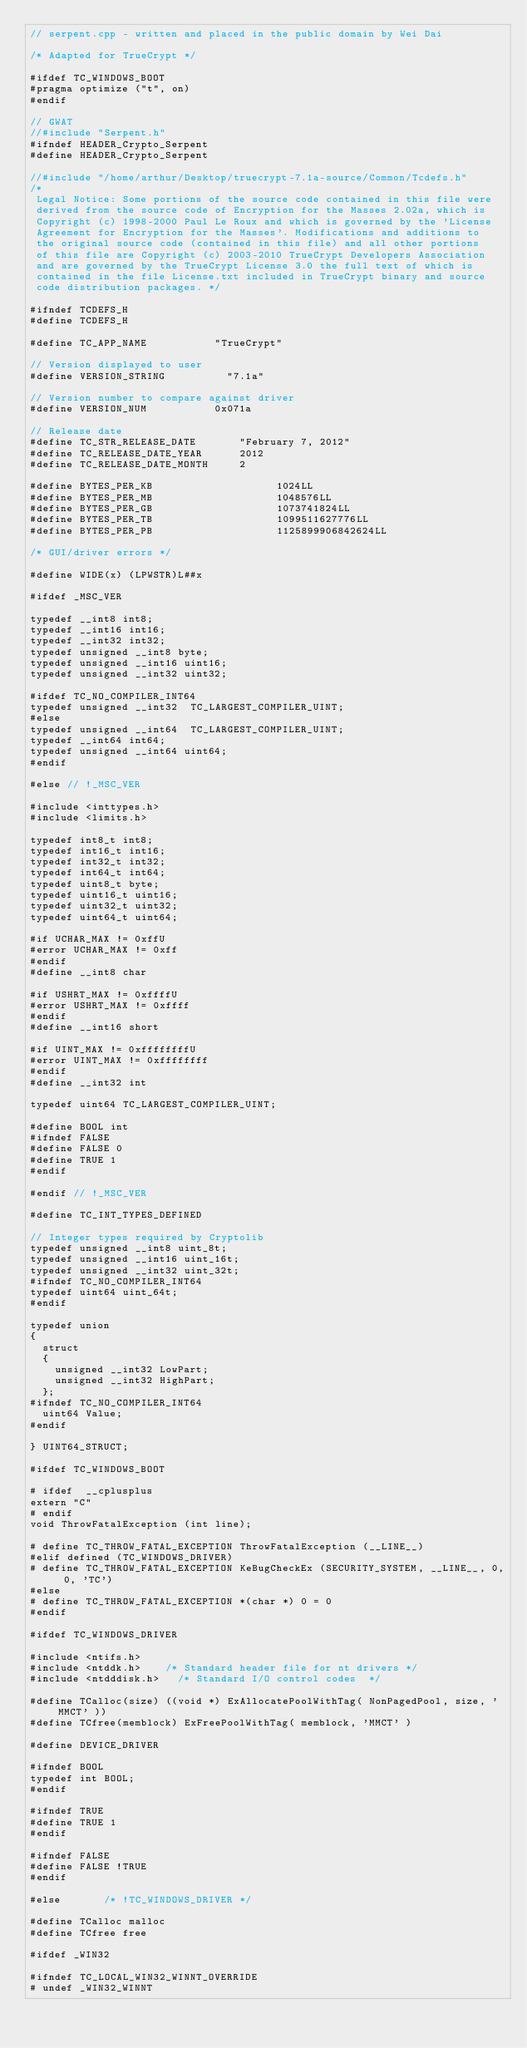Convert code to text. <code><loc_0><loc_0><loc_500><loc_500><_Cuda_>// serpent.cpp - written and placed in the public domain by Wei Dai

/* Adapted for TrueCrypt */

#ifdef TC_WINDOWS_BOOT
#pragma optimize ("t", on)
#endif

// GWAT
//#include "Serpent.h"
#ifndef HEADER_Crypto_Serpent
#define HEADER_Crypto_Serpent

//#include "/home/arthur/Desktop/truecrypt-7.1a-source/Common/Tcdefs.h"
/*
 Legal Notice: Some portions of the source code contained in this file were
 derived from the source code of Encryption for the Masses 2.02a, which is
 Copyright (c) 1998-2000 Paul Le Roux and which is governed by the 'License
 Agreement for Encryption for the Masses'. Modifications and additions to
 the original source code (contained in this file) and all other portions
 of this file are Copyright (c) 2003-2010 TrueCrypt Developers Association
 and are governed by the TrueCrypt License 3.0 the full text of which is
 contained in the file License.txt included in TrueCrypt binary and source
 code distribution packages. */

#ifndef TCDEFS_H
#define TCDEFS_H

#define TC_APP_NAME						"TrueCrypt"

// Version displayed to user 
#define VERSION_STRING					"7.1a"

// Version number to compare against driver
#define VERSION_NUM						0x071a

// Release date
#define TC_STR_RELEASE_DATE				"February 7, 2012"
#define TC_RELEASE_DATE_YEAR			2012
#define TC_RELEASE_DATE_MONTH			2

#define BYTES_PER_KB                    1024LL
#define BYTES_PER_MB                    1048576LL
#define BYTES_PER_GB                    1073741824LL
#define BYTES_PER_TB                    1099511627776LL
#define BYTES_PER_PB                    1125899906842624LL

/* GUI/driver errors */

#define WIDE(x) (LPWSTR)L##x

#ifdef _MSC_VER

typedef __int8 int8;
typedef __int16 int16;
typedef __int32 int32;
typedef unsigned __int8 byte;
typedef unsigned __int16 uint16;
typedef unsigned __int32 uint32;

#ifdef TC_NO_COMPILER_INT64
typedef unsigned __int32	TC_LARGEST_COMPILER_UINT;
#else
typedef unsigned __int64	TC_LARGEST_COMPILER_UINT;
typedef __int64 int64;
typedef unsigned __int64 uint64;
#endif

#else // !_MSC_VER

#include <inttypes.h>
#include <limits.h>

typedef int8_t int8;
typedef int16_t int16;
typedef int32_t int32;
typedef int64_t int64;
typedef uint8_t byte;
typedef uint16_t uint16;
typedef uint32_t uint32;
typedef uint64_t uint64;

#if UCHAR_MAX != 0xffU
#error UCHAR_MAX != 0xff
#endif
#define __int8 char

#if USHRT_MAX != 0xffffU
#error USHRT_MAX != 0xffff
#endif
#define __int16 short

#if UINT_MAX != 0xffffffffU
#error UINT_MAX != 0xffffffff
#endif
#define __int32 int

typedef uint64 TC_LARGEST_COMPILER_UINT;

#define BOOL int
#ifndef FALSE
#define FALSE 0
#define TRUE 1
#endif

#endif // !_MSC_VER

#define TC_INT_TYPES_DEFINED

// Integer types required by Cryptolib
typedef unsigned __int8 uint_8t;
typedef unsigned __int16 uint_16t;
typedef unsigned __int32 uint_32t;
#ifndef TC_NO_COMPILER_INT64
typedef uint64 uint_64t;
#endif

typedef union 
{
	struct 
	{
		unsigned __int32 LowPart;
		unsigned __int32 HighPart;
	};
#ifndef TC_NO_COMPILER_INT64
	uint64 Value;
#endif

} UINT64_STRUCT;

#ifdef TC_WINDOWS_BOOT

#	ifdef  __cplusplus
extern "C"
#	endif
void ThrowFatalException (int line);

#	define TC_THROW_FATAL_EXCEPTION	ThrowFatalException (__LINE__)
#elif defined (TC_WINDOWS_DRIVER)
#	define TC_THROW_FATAL_EXCEPTION KeBugCheckEx (SECURITY_SYSTEM, __LINE__, 0, 0, 'TC')
#else
#	define TC_THROW_FATAL_EXCEPTION	*(char *) 0 = 0
#endif

#ifdef TC_WINDOWS_DRIVER

#include <ntifs.h>
#include <ntddk.h>		/* Standard header file for nt drivers */
#include <ntdddisk.h>		/* Standard I/O control codes  */

#define TCalloc(size) ((void *) ExAllocatePoolWithTag( NonPagedPool, size, 'MMCT' ))
#define TCfree(memblock) ExFreePoolWithTag( memblock, 'MMCT' )

#define DEVICE_DRIVER

#ifndef BOOL
typedef int BOOL;
#endif

#ifndef TRUE
#define TRUE 1
#endif

#ifndef FALSE
#define FALSE !TRUE
#endif

#else				/* !TC_WINDOWS_DRIVER */

#define TCalloc malloc
#define TCfree free

#ifdef _WIN32

#ifndef TC_LOCAL_WIN32_WINNT_OVERRIDE
#	undef _WIN32_WINNT</code> 